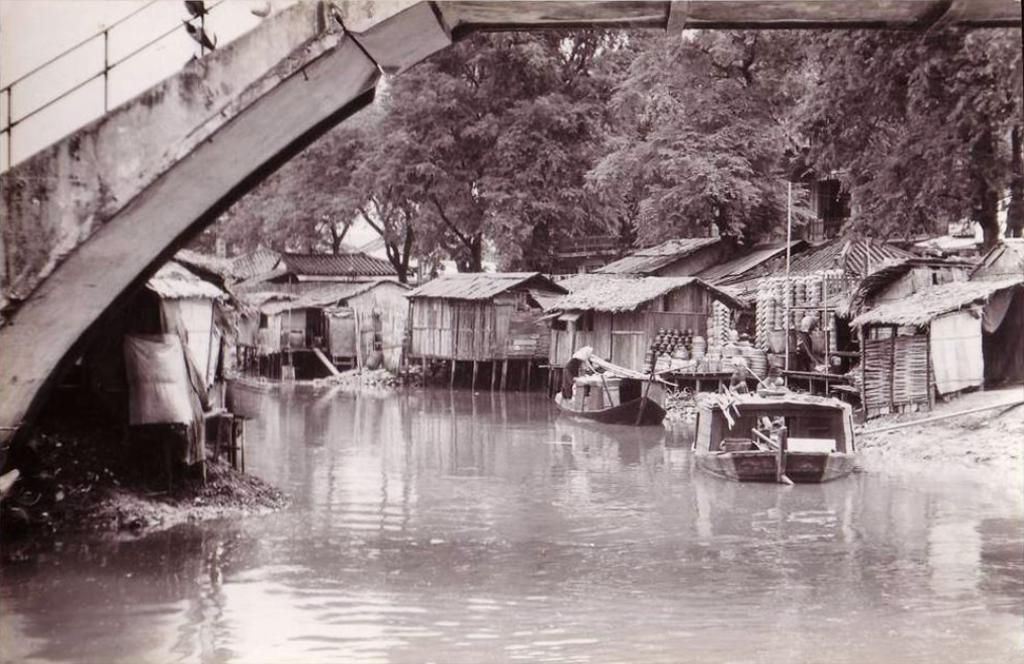What is on the water in the image? There are boats on the water in the image. What structure can be seen in the image? There is a bridge in the image. What type of vegetation is present in the image? There are trees in the image. What type of buildings can be seen in the image? There are houses with roofs in the image. What objects are placed beside a house in the image? Utensils are placed beside a house in the image. What is visible in the sky in the image? The sky is visible in the image. What type of flag is waving quietly in the image? There is no flag present in the image. How many points are visible on the starfish in the image? There is no starfish present in the image. 